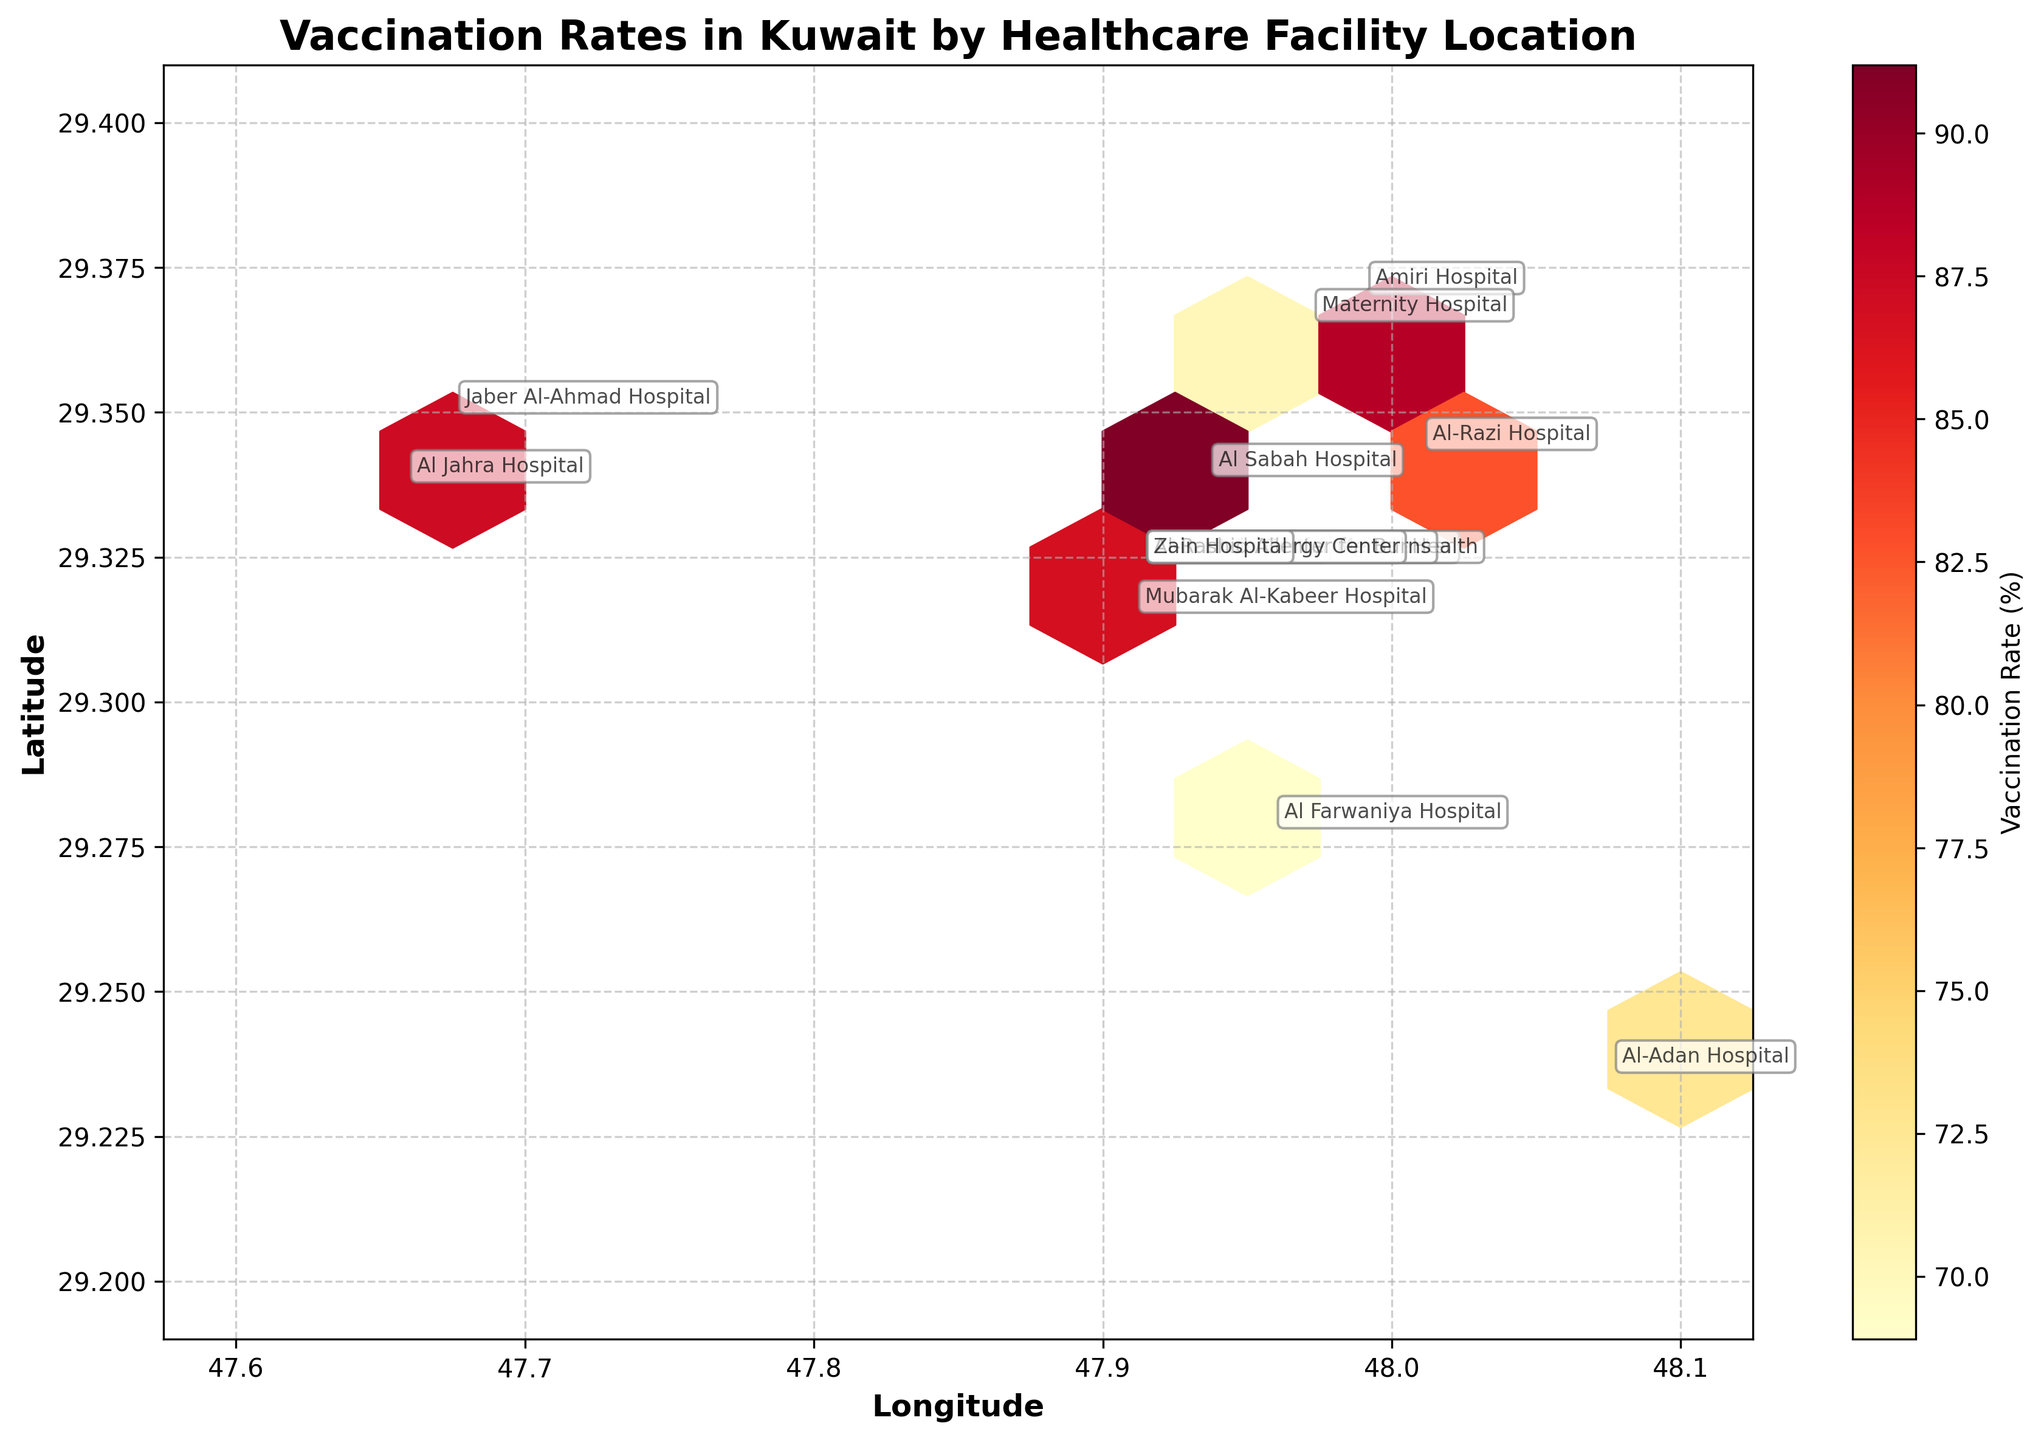What is the title of the figure? The title is displayed prominently at the top of the figure. It helps set the context for what the plot is representing.
Answer: Vaccination Rates in Kuwait by Healthcare Facility Location What are the x and y axes labels? The x and y axes labels provide information about what the values of the x and y coordinates represent. By looking at the axes labels, we know what dimensions are being plotted.
Answer: Longitude, Latitude Which healthcare facility has the highest vaccination rate? We need to identify the highest value on the color spectrum represented in the colormap, and find the corresponding healthcare facility name.
Answer: Kuwait Cancer Control Center How are vaccination rates distributed geographically in Kuwait? Observe the density and color intensity of hexagons in the plot. Darker and denser hexagons indicate higher rates, and the geographical distribution of those hexagons shows the spread of vaccination rates.
Answer: Higher rates are concentrated towards the center, with some high values spread out Compare the vaccination rates among the age groups at the Al Sabah Hospital. Extract the vaccination rates for each age group specific to Al Sabah Hospital and then compare these values.
Answer: 45-59: 91.2% Which healthcare facility located at approximately 29.3236 latitude and 47.9131 longitude has the highest vaccination rate? Identify the healthcare facility located at the mentioned coordinates with the highest vaccination rate.
Answer: Kuwait Cancer Control Center Does a specific age group tend to have higher vaccination rates at facilities located in the northern part of Kuwait? Look for facilities in the northern part of Kuwait and observe the vaccination rates of different age groups at these locations, comparing them to identify trends or patterns.
Answer: Yes, age group 60+ has higher rates in the north Are there any noticeable clusters of healthcare facilities with similar vaccination rates? Examine the hexbin plot for visually apparent clusters where the color of hexagons is similar, indicating similar vaccination rates.
Answer: Yes, central areas show clusters with high rates How does the vaccination rate at Al Farwaniya Hospital for age group 18-29 compare to Al-Adan Hospital for the same age group? Find the vaccination rates for age group 18-29 at both Al Farwaniya Hospital and Al-Adan Hospital, and compare them to see differences or similarities.
Answer: Al Farwaniya Hospital: 68.9%, Al-Adan Hospital: 72.5%; higher at Al-Adan Hospital Which age group has the lowest vaccination rate at the Maternity Hospital, and what is the value? Extract the vaccination rates for different age groups at the Maternity Hospital, then identify the one with the lowest value.
Answer: 18-29, 70.2% 